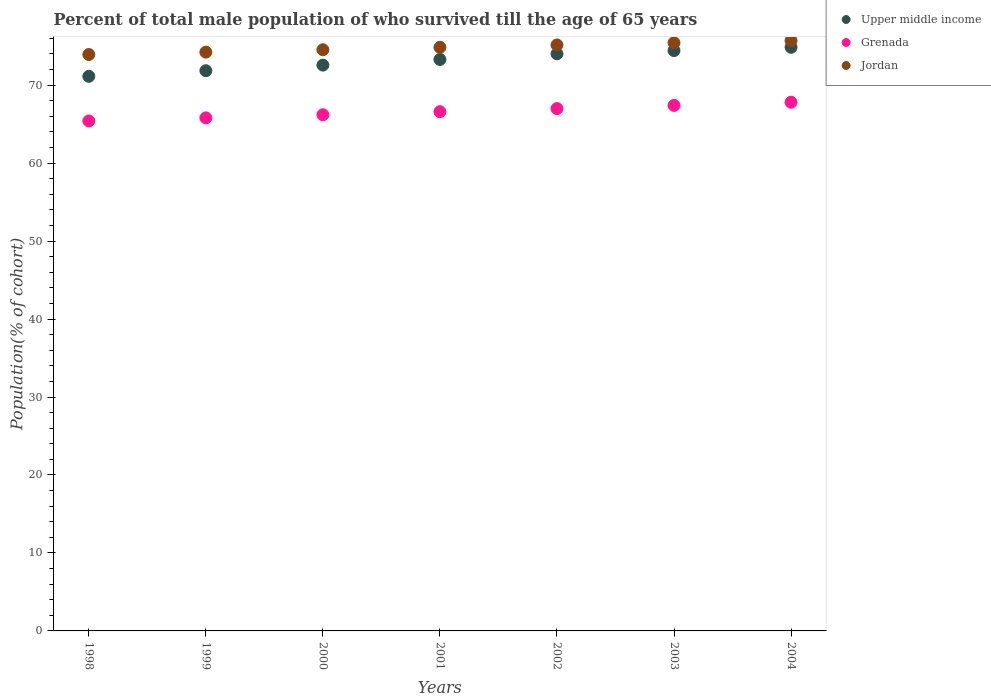Is the number of dotlines equal to the number of legend labels?
Keep it short and to the point. Yes. What is the percentage of total male population who survived till the age of 65 years in Upper middle income in 2001?
Provide a succinct answer. 73.29. Across all years, what is the maximum percentage of total male population who survived till the age of 65 years in Upper middle income?
Provide a short and direct response. 74.85. Across all years, what is the minimum percentage of total male population who survived till the age of 65 years in Jordan?
Ensure brevity in your answer.  73.93. In which year was the percentage of total male population who survived till the age of 65 years in Grenada minimum?
Your answer should be compact. 1998. What is the total percentage of total male population who survived till the age of 65 years in Grenada in the graph?
Give a very brief answer. 466.21. What is the difference between the percentage of total male population who survived till the age of 65 years in Jordan in 2000 and that in 2004?
Offer a very short reply. -1.17. What is the difference between the percentage of total male population who survived till the age of 65 years in Grenada in 2002 and the percentage of total male population who survived till the age of 65 years in Jordan in 1999?
Offer a very short reply. -7.24. What is the average percentage of total male population who survived till the age of 65 years in Jordan per year?
Your answer should be very brief. 74.84. In the year 2001, what is the difference between the percentage of total male population who survived till the age of 65 years in Jordan and percentage of total male population who survived till the age of 65 years in Upper middle income?
Make the answer very short. 1.56. In how many years, is the percentage of total male population who survived till the age of 65 years in Upper middle income greater than 22 %?
Your answer should be compact. 7. What is the ratio of the percentage of total male population who survived till the age of 65 years in Jordan in 2002 to that in 2003?
Provide a succinct answer. 1. Is the difference between the percentage of total male population who survived till the age of 65 years in Jordan in 1998 and 2002 greater than the difference between the percentage of total male population who survived till the age of 65 years in Upper middle income in 1998 and 2002?
Offer a terse response. Yes. What is the difference between the highest and the second highest percentage of total male population who survived till the age of 65 years in Upper middle income?
Make the answer very short. 0.42. What is the difference between the highest and the lowest percentage of total male population who survived till the age of 65 years in Upper middle income?
Offer a very short reply. 3.72. In how many years, is the percentage of total male population who survived till the age of 65 years in Jordan greater than the average percentage of total male population who survived till the age of 65 years in Jordan taken over all years?
Keep it short and to the point. 4. Is the sum of the percentage of total male population who survived till the age of 65 years in Jordan in 1999 and 2002 greater than the maximum percentage of total male population who survived till the age of 65 years in Upper middle income across all years?
Make the answer very short. Yes. Is it the case that in every year, the sum of the percentage of total male population who survived till the age of 65 years in Grenada and percentage of total male population who survived till the age of 65 years in Upper middle income  is greater than the percentage of total male population who survived till the age of 65 years in Jordan?
Your response must be concise. Yes. Does the percentage of total male population who survived till the age of 65 years in Grenada monotonically increase over the years?
Keep it short and to the point. Yes. Are the values on the major ticks of Y-axis written in scientific E-notation?
Provide a short and direct response. No. Does the graph contain any zero values?
Your answer should be compact. No. How many legend labels are there?
Ensure brevity in your answer.  3. What is the title of the graph?
Your response must be concise. Percent of total male population of who survived till the age of 65 years. Does "Zambia" appear as one of the legend labels in the graph?
Keep it short and to the point. No. What is the label or title of the X-axis?
Keep it short and to the point. Years. What is the label or title of the Y-axis?
Provide a succinct answer. Population(% of cohort). What is the Population(% of cohort) of Upper middle income in 1998?
Offer a terse response. 71.13. What is the Population(% of cohort) in Grenada in 1998?
Provide a short and direct response. 65.41. What is the Population(% of cohort) of Jordan in 1998?
Provide a short and direct response. 73.93. What is the Population(% of cohort) in Upper middle income in 1999?
Provide a succinct answer. 71.85. What is the Population(% of cohort) in Grenada in 1999?
Your response must be concise. 65.8. What is the Population(% of cohort) of Jordan in 1999?
Make the answer very short. 74.23. What is the Population(% of cohort) of Upper middle income in 2000?
Ensure brevity in your answer.  72.57. What is the Population(% of cohort) in Grenada in 2000?
Ensure brevity in your answer.  66.2. What is the Population(% of cohort) of Jordan in 2000?
Ensure brevity in your answer.  74.54. What is the Population(% of cohort) in Upper middle income in 2001?
Your response must be concise. 73.29. What is the Population(% of cohort) of Grenada in 2001?
Ensure brevity in your answer.  66.6. What is the Population(% of cohort) in Jordan in 2001?
Provide a short and direct response. 74.85. What is the Population(% of cohort) in Upper middle income in 2002?
Your answer should be very brief. 74.02. What is the Population(% of cohort) in Grenada in 2002?
Your answer should be compact. 66.99. What is the Population(% of cohort) in Jordan in 2002?
Make the answer very short. 75.16. What is the Population(% of cohort) in Upper middle income in 2003?
Make the answer very short. 74.44. What is the Population(% of cohort) of Grenada in 2003?
Provide a succinct answer. 67.4. What is the Population(% of cohort) of Jordan in 2003?
Ensure brevity in your answer.  75.43. What is the Population(% of cohort) in Upper middle income in 2004?
Your answer should be very brief. 74.85. What is the Population(% of cohort) of Grenada in 2004?
Your answer should be very brief. 67.81. What is the Population(% of cohort) in Jordan in 2004?
Keep it short and to the point. 75.71. Across all years, what is the maximum Population(% of cohort) in Upper middle income?
Provide a short and direct response. 74.85. Across all years, what is the maximum Population(% of cohort) of Grenada?
Offer a terse response. 67.81. Across all years, what is the maximum Population(% of cohort) of Jordan?
Give a very brief answer. 75.71. Across all years, what is the minimum Population(% of cohort) of Upper middle income?
Provide a short and direct response. 71.13. Across all years, what is the minimum Population(% of cohort) of Grenada?
Ensure brevity in your answer.  65.41. Across all years, what is the minimum Population(% of cohort) in Jordan?
Offer a terse response. 73.93. What is the total Population(% of cohort) in Upper middle income in the graph?
Provide a succinct answer. 512.14. What is the total Population(% of cohort) in Grenada in the graph?
Provide a succinct answer. 466.21. What is the total Population(% of cohort) of Jordan in the graph?
Give a very brief answer. 523.86. What is the difference between the Population(% of cohort) of Upper middle income in 1998 and that in 1999?
Your answer should be compact. -0.72. What is the difference between the Population(% of cohort) in Grenada in 1998 and that in 1999?
Give a very brief answer. -0.4. What is the difference between the Population(% of cohort) in Jordan in 1998 and that in 1999?
Offer a very short reply. -0.31. What is the difference between the Population(% of cohort) in Upper middle income in 1998 and that in 2000?
Keep it short and to the point. -1.44. What is the difference between the Population(% of cohort) in Grenada in 1998 and that in 2000?
Keep it short and to the point. -0.79. What is the difference between the Population(% of cohort) in Jordan in 1998 and that in 2000?
Provide a short and direct response. -0.61. What is the difference between the Population(% of cohort) of Upper middle income in 1998 and that in 2001?
Give a very brief answer. -2.16. What is the difference between the Population(% of cohort) in Grenada in 1998 and that in 2001?
Make the answer very short. -1.19. What is the difference between the Population(% of cohort) of Jordan in 1998 and that in 2001?
Your response must be concise. -0.92. What is the difference between the Population(% of cohort) of Upper middle income in 1998 and that in 2002?
Keep it short and to the point. -2.88. What is the difference between the Population(% of cohort) in Grenada in 1998 and that in 2002?
Make the answer very short. -1.59. What is the difference between the Population(% of cohort) in Jordan in 1998 and that in 2002?
Provide a short and direct response. -1.23. What is the difference between the Population(% of cohort) of Upper middle income in 1998 and that in 2003?
Offer a terse response. -3.3. What is the difference between the Population(% of cohort) in Grenada in 1998 and that in 2003?
Your response must be concise. -1.99. What is the difference between the Population(% of cohort) of Jordan in 1998 and that in 2003?
Offer a very short reply. -1.51. What is the difference between the Population(% of cohort) of Upper middle income in 1998 and that in 2004?
Your answer should be very brief. -3.72. What is the difference between the Population(% of cohort) in Grenada in 1998 and that in 2004?
Give a very brief answer. -2.4. What is the difference between the Population(% of cohort) of Jordan in 1998 and that in 2004?
Provide a succinct answer. -1.79. What is the difference between the Population(% of cohort) in Upper middle income in 1999 and that in 2000?
Your answer should be compact. -0.72. What is the difference between the Population(% of cohort) of Grenada in 1999 and that in 2000?
Ensure brevity in your answer.  -0.4. What is the difference between the Population(% of cohort) in Jordan in 1999 and that in 2000?
Your answer should be compact. -0.31. What is the difference between the Population(% of cohort) of Upper middle income in 1999 and that in 2001?
Keep it short and to the point. -1.44. What is the difference between the Population(% of cohort) of Grenada in 1999 and that in 2001?
Your answer should be very brief. -0.79. What is the difference between the Population(% of cohort) of Jordan in 1999 and that in 2001?
Make the answer very short. -0.61. What is the difference between the Population(% of cohort) of Upper middle income in 1999 and that in 2002?
Your response must be concise. -2.17. What is the difference between the Population(% of cohort) in Grenada in 1999 and that in 2002?
Provide a short and direct response. -1.19. What is the difference between the Population(% of cohort) of Jordan in 1999 and that in 2002?
Your answer should be very brief. -0.92. What is the difference between the Population(% of cohort) of Upper middle income in 1999 and that in 2003?
Offer a very short reply. -2.59. What is the difference between the Population(% of cohort) in Grenada in 1999 and that in 2003?
Offer a very short reply. -1.6. What is the difference between the Population(% of cohort) of Jordan in 1999 and that in 2003?
Your response must be concise. -1.2. What is the difference between the Population(% of cohort) of Upper middle income in 1999 and that in 2004?
Offer a very short reply. -3. What is the difference between the Population(% of cohort) of Grenada in 1999 and that in 2004?
Make the answer very short. -2. What is the difference between the Population(% of cohort) in Jordan in 1999 and that in 2004?
Your answer should be compact. -1.48. What is the difference between the Population(% of cohort) of Upper middle income in 2000 and that in 2001?
Ensure brevity in your answer.  -0.72. What is the difference between the Population(% of cohort) of Grenada in 2000 and that in 2001?
Your answer should be very brief. -0.4. What is the difference between the Population(% of cohort) in Jordan in 2000 and that in 2001?
Your response must be concise. -0.31. What is the difference between the Population(% of cohort) in Upper middle income in 2000 and that in 2002?
Your answer should be very brief. -1.45. What is the difference between the Population(% of cohort) of Grenada in 2000 and that in 2002?
Offer a very short reply. -0.79. What is the difference between the Population(% of cohort) of Jordan in 2000 and that in 2002?
Offer a terse response. -0.61. What is the difference between the Population(% of cohort) in Upper middle income in 2000 and that in 2003?
Keep it short and to the point. -1.87. What is the difference between the Population(% of cohort) in Grenada in 2000 and that in 2003?
Ensure brevity in your answer.  -1.2. What is the difference between the Population(% of cohort) of Jordan in 2000 and that in 2003?
Your response must be concise. -0.89. What is the difference between the Population(% of cohort) of Upper middle income in 2000 and that in 2004?
Make the answer very short. -2.28. What is the difference between the Population(% of cohort) of Grenada in 2000 and that in 2004?
Provide a succinct answer. -1.61. What is the difference between the Population(% of cohort) in Jordan in 2000 and that in 2004?
Give a very brief answer. -1.17. What is the difference between the Population(% of cohort) of Upper middle income in 2001 and that in 2002?
Make the answer very short. -0.73. What is the difference between the Population(% of cohort) in Grenada in 2001 and that in 2002?
Offer a very short reply. -0.4. What is the difference between the Population(% of cohort) in Jordan in 2001 and that in 2002?
Provide a succinct answer. -0.31. What is the difference between the Population(% of cohort) of Upper middle income in 2001 and that in 2003?
Your answer should be very brief. -1.14. What is the difference between the Population(% of cohort) in Grenada in 2001 and that in 2003?
Your answer should be very brief. -0.8. What is the difference between the Population(% of cohort) in Jordan in 2001 and that in 2003?
Offer a terse response. -0.59. What is the difference between the Population(% of cohort) in Upper middle income in 2001 and that in 2004?
Your response must be concise. -1.56. What is the difference between the Population(% of cohort) of Grenada in 2001 and that in 2004?
Keep it short and to the point. -1.21. What is the difference between the Population(% of cohort) of Jordan in 2001 and that in 2004?
Your answer should be very brief. -0.86. What is the difference between the Population(% of cohort) of Upper middle income in 2002 and that in 2003?
Provide a succinct answer. -0.42. What is the difference between the Population(% of cohort) in Grenada in 2002 and that in 2003?
Offer a terse response. -0.41. What is the difference between the Population(% of cohort) in Jordan in 2002 and that in 2003?
Your response must be concise. -0.28. What is the difference between the Population(% of cohort) of Upper middle income in 2002 and that in 2004?
Offer a terse response. -0.83. What is the difference between the Population(% of cohort) of Grenada in 2002 and that in 2004?
Give a very brief answer. -0.81. What is the difference between the Population(% of cohort) in Jordan in 2002 and that in 2004?
Give a very brief answer. -0.56. What is the difference between the Population(% of cohort) in Upper middle income in 2003 and that in 2004?
Keep it short and to the point. -0.42. What is the difference between the Population(% of cohort) in Grenada in 2003 and that in 2004?
Your answer should be very brief. -0.41. What is the difference between the Population(% of cohort) of Jordan in 2003 and that in 2004?
Your response must be concise. -0.28. What is the difference between the Population(% of cohort) in Upper middle income in 1998 and the Population(% of cohort) in Grenada in 1999?
Provide a succinct answer. 5.33. What is the difference between the Population(% of cohort) in Upper middle income in 1998 and the Population(% of cohort) in Jordan in 1999?
Keep it short and to the point. -3.1. What is the difference between the Population(% of cohort) of Grenada in 1998 and the Population(% of cohort) of Jordan in 1999?
Provide a succinct answer. -8.83. What is the difference between the Population(% of cohort) in Upper middle income in 1998 and the Population(% of cohort) in Grenada in 2000?
Provide a short and direct response. 4.93. What is the difference between the Population(% of cohort) of Upper middle income in 1998 and the Population(% of cohort) of Jordan in 2000?
Offer a terse response. -3.41. What is the difference between the Population(% of cohort) in Grenada in 1998 and the Population(% of cohort) in Jordan in 2000?
Keep it short and to the point. -9.13. What is the difference between the Population(% of cohort) in Upper middle income in 1998 and the Population(% of cohort) in Grenada in 2001?
Your answer should be very brief. 4.54. What is the difference between the Population(% of cohort) of Upper middle income in 1998 and the Population(% of cohort) of Jordan in 2001?
Your answer should be compact. -3.72. What is the difference between the Population(% of cohort) in Grenada in 1998 and the Population(% of cohort) in Jordan in 2001?
Provide a short and direct response. -9.44. What is the difference between the Population(% of cohort) in Upper middle income in 1998 and the Population(% of cohort) in Grenada in 2002?
Make the answer very short. 4.14. What is the difference between the Population(% of cohort) in Upper middle income in 1998 and the Population(% of cohort) in Jordan in 2002?
Your response must be concise. -4.02. What is the difference between the Population(% of cohort) of Grenada in 1998 and the Population(% of cohort) of Jordan in 2002?
Offer a terse response. -9.75. What is the difference between the Population(% of cohort) in Upper middle income in 1998 and the Population(% of cohort) in Grenada in 2003?
Offer a terse response. 3.73. What is the difference between the Population(% of cohort) of Upper middle income in 1998 and the Population(% of cohort) of Jordan in 2003?
Give a very brief answer. -4.3. What is the difference between the Population(% of cohort) in Grenada in 1998 and the Population(% of cohort) in Jordan in 2003?
Your answer should be compact. -10.03. What is the difference between the Population(% of cohort) in Upper middle income in 1998 and the Population(% of cohort) in Grenada in 2004?
Keep it short and to the point. 3.33. What is the difference between the Population(% of cohort) in Upper middle income in 1998 and the Population(% of cohort) in Jordan in 2004?
Offer a terse response. -4.58. What is the difference between the Population(% of cohort) of Grenada in 1998 and the Population(% of cohort) of Jordan in 2004?
Offer a terse response. -10.31. What is the difference between the Population(% of cohort) of Upper middle income in 1999 and the Population(% of cohort) of Grenada in 2000?
Your answer should be very brief. 5.65. What is the difference between the Population(% of cohort) in Upper middle income in 1999 and the Population(% of cohort) in Jordan in 2000?
Provide a short and direct response. -2.69. What is the difference between the Population(% of cohort) of Grenada in 1999 and the Population(% of cohort) of Jordan in 2000?
Your answer should be very brief. -8.74. What is the difference between the Population(% of cohort) in Upper middle income in 1999 and the Population(% of cohort) in Grenada in 2001?
Ensure brevity in your answer.  5.25. What is the difference between the Population(% of cohort) in Upper middle income in 1999 and the Population(% of cohort) in Jordan in 2001?
Offer a terse response. -3. What is the difference between the Population(% of cohort) in Grenada in 1999 and the Population(% of cohort) in Jordan in 2001?
Keep it short and to the point. -9.04. What is the difference between the Population(% of cohort) of Upper middle income in 1999 and the Population(% of cohort) of Grenada in 2002?
Keep it short and to the point. 4.86. What is the difference between the Population(% of cohort) of Upper middle income in 1999 and the Population(% of cohort) of Jordan in 2002?
Your response must be concise. -3.31. What is the difference between the Population(% of cohort) of Grenada in 1999 and the Population(% of cohort) of Jordan in 2002?
Give a very brief answer. -9.35. What is the difference between the Population(% of cohort) in Upper middle income in 1999 and the Population(% of cohort) in Grenada in 2003?
Your response must be concise. 4.45. What is the difference between the Population(% of cohort) in Upper middle income in 1999 and the Population(% of cohort) in Jordan in 2003?
Your response must be concise. -3.58. What is the difference between the Population(% of cohort) of Grenada in 1999 and the Population(% of cohort) of Jordan in 2003?
Provide a short and direct response. -9.63. What is the difference between the Population(% of cohort) in Upper middle income in 1999 and the Population(% of cohort) in Grenada in 2004?
Provide a short and direct response. 4.04. What is the difference between the Population(% of cohort) of Upper middle income in 1999 and the Population(% of cohort) of Jordan in 2004?
Provide a succinct answer. -3.86. What is the difference between the Population(% of cohort) of Grenada in 1999 and the Population(% of cohort) of Jordan in 2004?
Your answer should be compact. -9.91. What is the difference between the Population(% of cohort) in Upper middle income in 2000 and the Population(% of cohort) in Grenada in 2001?
Give a very brief answer. 5.97. What is the difference between the Population(% of cohort) in Upper middle income in 2000 and the Population(% of cohort) in Jordan in 2001?
Keep it short and to the point. -2.28. What is the difference between the Population(% of cohort) in Grenada in 2000 and the Population(% of cohort) in Jordan in 2001?
Your response must be concise. -8.65. What is the difference between the Population(% of cohort) in Upper middle income in 2000 and the Population(% of cohort) in Grenada in 2002?
Your answer should be very brief. 5.57. What is the difference between the Population(% of cohort) of Upper middle income in 2000 and the Population(% of cohort) of Jordan in 2002?
Offer a terse response. -2.59. What is the difference between the Population(% of cohort) in Grenada in 2000 and the Population(% of cohort) in Jordan in 2002?
Offer a very short reply. -8.95. What is the difference between the Population(% of cohort) in Upper middle income in 2000 and the Population(% of cohort) in Grenada in 2003?
Give a very brief answer. 5.17. What is the difference between the Population(% of cohort) of Upper middle income in 2000 and the Population(% of cohort) of Jordan in 2003?
Your response must be concise. -2.87. What is the difference between the Population(% of cohort) in Grenada in 2000 and the Population(% of cohort) in Jordan in 2003?
Make the answer very short. -9.23. What is the difference between the Population(% of cohort) of Upper middle income in 2000 and the Population(% of cohort) of Grenada in 2004?
Your answer should be very brief. 4.76. What is the difference between the Population(% of cohort) of Upper middle income in 2000 and the Population(% of cohort) of Jordan in 2004?
Your answer should be very brief. -3.15. What is the difference between the Population(% of cohort) in Grenada in 2000 and the Population(% of cohort) in Jordan in 2004?
Give a very brief answer. -9.51. What is the difference between the Population(% of cohort) in Upper middle income in 2001 and the Population(% of cohort) in Grenada in 2002?
Make the answer very short. 6.3. What is the difference between the Population(% of cohort) in Upper middle income in 2001 and the Population(% of cohort) in Jordan in 2002?
Make the answer very short. -1.86. What is the difference between the Population(% of cohort) of Grenada in 2001 and the Population(% of cohort) of Jordan in 2002?
Your response must be concise. -8.56. What is the difference between the Population(% of cohort) in Upper middle income in 2001 and the Population(% of cohort) in Grenada in 2003?
Offer a terse response. 5.89. What is the difference between the Population(% of cohort) of Upper middle income in 2001 and the Population(% of cohort) of Jordan in 2003?
Your answer should be compact. -2.14. What is the difference between the Population(% of cohort) in Grenada in 2001 and the Population(% of cohort) in Jordan in 2003?
Ensure brevity in your answer.  -8.84. What is the difference between the Population(% of cohort) in Upper middle income in 2001 and the Population(% of cohort) in Grenada in 2004?
Provide a short and direct response. 5.48. What is the difference between the Population(% of cohort) of Upper middle income in 2001 and the Population(% of cohort) of Jordan in 2004?
Offer a terse response. -2.42. What is the difference between the Population(% of cohort) in Grenada in 2001 and the Population(% of cohort) in Jordan in 2004?
Ensure brevity in your answer.  -9.12. What is the difference between the Population(% of cohort) in Upper middle income in 2002 and the Population(% of cohort) in Grenada in 2003?
Offer a terse response. 6.62. What is the difference between the Population(% of cohort) in Upper middle income in 2002 and the Population(% of cohort) in Jordan in 2003?
Offer a very short reply. -1.42. What is the difference between the Population(% of cohort) of Grenada in 2002 and the Population(% of cohort) of Jordan in 2003?
Your response must be concise. -8.44. What is the difference between the Population(% of cohort) in Upper middle income in 2002 and the Population(% of cohort) in Grenada in 2004?
Provide a short and direct response. 6.21. What is the difference between the Population(% of cohort) in Upper middle income in 2002 and the Population(% of cohort) in Jordan in 2004?
Offer a terse response. -1.7. What is the difference between the Population(% of cohort) in Grenada in 2002 and the Population(% of cohort) in Jordan in 2004?
Offer a very short reply. -8.72. What is the difference between the Population(% of cohort) in Upper middle income in 2003 and the Population(% of cohort) in Grenada in 2004?
Provide a succinct answer. 6.63. What is the difference between the Population(% of cohort) in Upper middle income in 2003 and the Population(% of cohort) in Jordan in 2004?
Provide a succinct answer. -1.28. What is the difference between the Population(% of cohort) of Grenada in 2003 and the Population(% of cohort) of Jordan in 2004?
Your response must be concise. -8.31. What is the average Population(% of cohort) in Upper middle income per year?
Keep it short and to the point. 73.16. What is the average Population(% of cohort) of Grenada per year?
Your response must be concise. 66.6. What is the average Population(% of cohort) in Jordan per year?
Your answer should be very brief. 74.84. In the year 1998, what is the difference between the Population(% of cohort) of Upper middle income and Population(% of cohort) of Grenada?
Offer a terse response. 5.72. In the year 1998, what is the difference between the Population(% of cohort) in Upper middle income and Population(% of cohort) in Jordan?
Provide a succinct answer. -2.79. In the year 1998, what is the difference between the Population(% of cohort) of Grenada and Population(% of cohort) of Jordan?
Ensure brevity in your answer.  -8.52. In the year 1999, what is the difference between the Population(% of cohort) of Upper middle income and Population(% of cohort) of Grenada?
Keep it short and to the point. 6.04. In the year 1999, what is the difference between the Population(% of cohort) in Upper middle income and Population(% of cohort) in Jordan?
Your answer should be very brief. -2.38. In the year 1999, what is the difference between the Population(% of cohort) of Grenada and Population(% of cohort) of Jordan?
Your answer should be very brief. -8.43. In the year 2000, what is the difference between the Population(% of cohort) of Upper middle income and Population(% of cohort) of Grenada?
Provide a short and direct response. 6.37. In the year 2000, what is the difference between the Population(% of cohort) of Upper middle income and Population(% of cohort) of Jordan?
Ensure brevity in your answer.  -1.97. In the year 2000, what is the difference between the Population(% of cohort) in Grenada and Population(% of cohort) in Jordan?
Make the answer very short. -8.34. In the year 2001, what is the difference between the Population(% of cohort) of Upper middle income and Population(% of cohort) of Grenada?
Your answer should be compact. 6.69. In the year 2001, what is the difference between the Population(% of cohort) in Upper middle income and Population(% of cohort) in Jordan?
Offer a terse response. -1.56. In the year 2001, what is the difference between the Population(% of cohort) of Grenada and Population(% of cohort) of Jordan?
Your answer should be compact. -8.25. In the year 2002, what is the difference between the Population(% of cohort) in Upper middle income and Population(% of cohort) in Grenada?
Offer a very short reply. 7.02. In the year 2002, what is the difference between the Population(% of cohort) in Upper middle income and Population(% of cohort) in Jordan?
Make the answer very short. -1.14. In the year 2002, what is the difference between the Population(% of cohort) of Grenada and Population(% of cohort) of Jordan?
Provide a short and direct response. -8.16. In the year 2003, what is the difference between the Population(% of cohort) in Upper middle income and Population(% of cohort) in Grenada?
Your answer should be compact. 7.04. In the year 2003, what is the difference between the Population(% of cohort) in Upper middle income and Population(% of cohort) in Jordan?
Your response must be concise. -1. In the year 2003, what is the difference between the Population(% of cohort) in Grenada and Population(% of cohort) in Jordan?
Your answer should be very brief. -8.03. In the year 2004, what is the difference between the Population(% of cohort) of Upper middle income and Population(% of cohort) of Grenada?
Your response must be concise. 7.04. In the year 2004, what is the difference between the Population(% of cohort) in Upper middle income and Population(% of cohort) in Jordan?
Your answer should be very brief. -0.86. In the year 2004, what is the difference between the Population(% of cohort) of Grenada and Population(% of cohort) of Jordan?
Make the answer very short. -7.91. What is the ratio of the Population(% of cohort) of Jordan in 1998 to that in 1999?
Offer a very short reply. 1. What is the ratio of the Population(% of cohort) in Upper middle income in 1998 to that in 2000?
Make the answer very short. 0.98. What is the ratio of the Population(% of cohort) of Grenada in 1998 to that in 2000?
Offer a very short reply. 0.99. What is the ratio of the Population(% of cohort) of Upper middle income in 1998 to that in 2001?
Give a very brief answer. 0.97. What is the ratio of the Population(% of cohort) of Grenada in 1998 to that in 2001?
Your response must be concise. 0.98. What is the ratio of the Population(% of cohort) in Upper middle income in 1998 to that in 2002?
Give a very brief answer. 0.96. What is the ratio of the Population(% of cohort) of Grenada in 1998 to that in 2002?
Offer a terse response. 0.98. What is the ratio of the Population(% of cohort) of Jordan in 1998 to that in 2002?
Ensure brevity in your answer.  0.98. What is the ratio of the Population(% of cohort) of Upper middle income in 1998 to that in 2003?
Provide a short and direct response. 0.96. What is the ratio of the Population(% of cohort) of Grenada in 1998 to that in 2003?
Offer a terse response. 0.97. What is the ratio of the Population(% of cohort) of Upper middle income in 1998 to that in 2004?
Offer a terse response. 0.95. What is the ratio of the Population(% of cohort) in Grenada in 1998 to that in 2004?
Provide a succinct answer. 0.96. What is the ratio of the Population(% of cohort) in Jordan in 1998 to that in 2004?
Keep it short and to the point. 0.98. What is the ratio of the Population(% of cohort) of Upper middle income in 1999 to that in 2000?
Your answer should be very brief. 0.99. What is the ratio of the Population(% of cohort) of Grenada in 1999 to that in 2000?
Your response must be concise. 0.99. What is the ratio of the Population(% of cohort) of Jordan in 1999 to that in 2000?
Provide a succinct answer. 1. What is the ratio of the Population(% of cohort) of Upper middle income in 1999 to that in 2001?
Provide a succinct answer. 0.98. What is the ratio of the Population(% of cohort) in Grenada in 1999 to that in 2001?
Your response must be concise. 0.99. What is the ratio of the Population(% of cohort) in Upper middle income in 1999 to that in 2002?
Ensure brevity in your answer.  0.97. What is the ratio of the Population(% of cohort) in Grenada in 1999 to that in 2002?
Give a very brief answer. 0.98. What is the ratio of the Population(% of cohort) in Jordan in 1999 to that in 2002?
Ensure brevity in your answer.  0.99. What is the ratio of the Population(% of cohort) in Upper middle income in 1999 to that in 2003?
Ensure brevity in your answer.  0.97. What is the ratio of the Population(% of cohort) of Grenada in 1999 to that in 2003?
Make the answer very short. 0.98. What is the ratio of the Population(% of cohort) in Jordan in 1999 to that in 2003?
Your answer should be very brief. 0.98. What is the ratio of the Population(% of cohort) in Upper middle income in 1999 to that in 2004?
Your answer should be very brief. 0.96. What is the ratio of the Population(% of cohort) in Grenada in 1999 to that in 2004?
Provide a succinct answer. 0.97. What is the ratio of the Population(% of cohort) of Jordan in 1999 to that in 2004?
Ensure brevity in your answer.  0.98. What is the ratio of the Population(% of cohort) of Jordan in 2000 to that in 2001?
Your response must be concise. 1. What is the ratio of the Population(% of cohort) of Upper middle income in 2000 to that in 2002?
Keep it short and to the point. 0.98. What is the ratio of the Population(% of cohort) in Grenada in 2000 to that in 2002?
Give a very brief answer. 0.99. What is the ratio of the Population(% of cohort) in Jordan in 2000 to that in 2002?
Your answer should be compact. 0.99. What is the ratio of the Population(% of cohort) in Upper middle income in 2000 to that in 2003?
Ensure brevity in your answer.  0.97. What is the ratio of the Population(% of cohort) of Grenada in 2000 to that in 2003?
Provide a short and direct response. 0.98. What is the ratio of the Population(% of cohort) of Upper middle income in 2000 to that in 2004?
Provide a succinct answer. 0.97. What is the ratio of the Population(% of cohort) of Grenada in 2000 to that in 2004?
Ensure brevity in your answer.  0.98. What is the ratio of the Population(% of cohort) in Jordan in 2000 to that in 2004?
Keep it short and to the point. 0.98. What is the ratio of the Population(% of cohort) of Upper middle income in 2001 to that in 2002?
Give a very brief answer. 0.99. What is the ratio of the Population(% of cohort) in Jordan in 2001 to that in 2002?
Offer a terse response. 1. What is the ratio of the Population(% of cohort) of Upper middle income in 2001 to that in 2003?
Your response must be concise. 0.98. What is the ratio of the Population(% of cohort) of Grenada in 2001 to that in 2003?
Keep it short and to the point. 0.99. What is the ratio of the Population(% of cohort) of Upper middle income in 2001 to that in 2004?
Ensure brevity in your answer.  0.98. What is the ratio of the Population(% of cohort) in Grenada in 2001 to that in 2004?
Ensure brevity in your answer.  0.98. What is the ratio of the Population(% of cohort) of Jordan in 2001 to that in 2004?
Your response must be concise. 0.99. What is the ratio of the Population(% of cohort) in Jordan in 2002 to that in 2003?
Make the answer very short. 1. What is the ratio of the Population(% of cohort) of Upper middle income in 2002 to that in 2004?
Provide a succinct answer. 0.99. What is the ratio of the Population(% of cohort) of Jordan in 2002 to that in 2004?
Provide a short and direct response. 0.99. What is the ratio of the Population(% of cohort) in Upper middle income in 2003 to that in 2004?
Provide a succinct answer. 0.99. What is the ratio of the Population(% of cohort) in Jordan in 2003 to that in 2004?
Make the answer very short. 1. What is the difference between the highest and the second highest Population(% of cohort) of Upper middle income?
Give a very brief answer. 0.42. What is the difference between the highest and the second highest Population(% of cohort) of Grenada?
Provide a succinct answer. 0.41. What is the difference between the highest and the second highest Population(% of cohort) in Jordan?
Your response must be concise. 0.28. What is the difference between the highest and the lowest Population(% of cohort) of Upper middle income?
Provide a short and direct response. 3.72. What is the difference between the highest and the lowest Population(% of cohort) of Grenada?
Provide a short and direct response. 2.4. What is the difference between the highest and the lowest Population(% of cohort) in Jordan?
Your answer should be very brief. 1.79. 